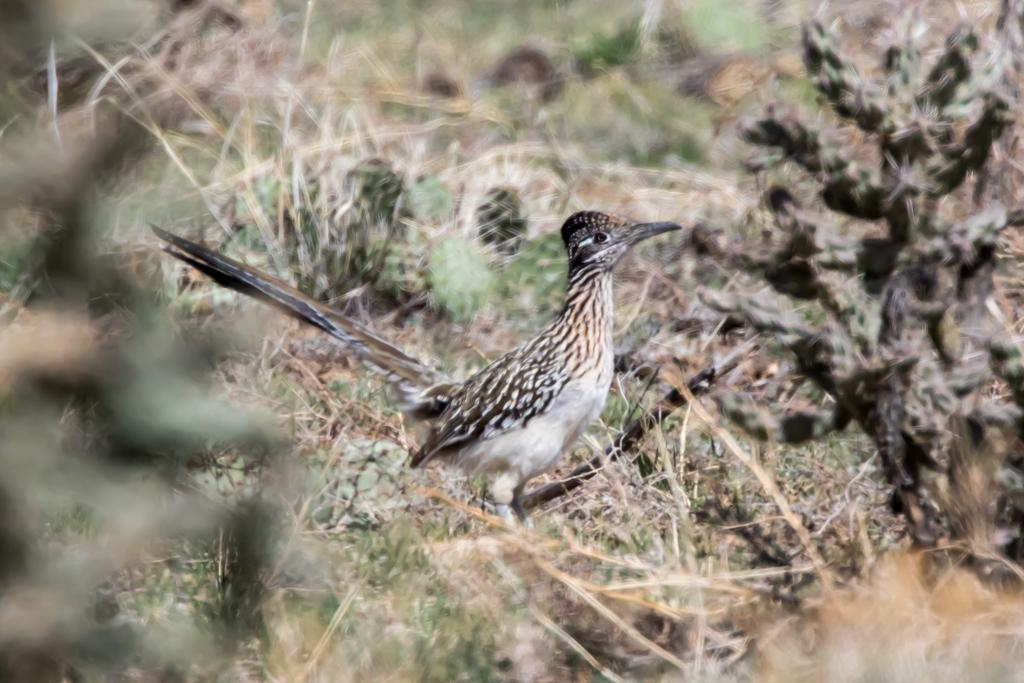What type of vegetation can be seen in the image? There is dry grass in the image. What type of animal is present in the image? There is a bird in the image. How many toes does the bird have in the image? The image does not show the bird's toes, so it cannot be determined from the image. What is the bird's position during its birth in the image? The image does not show the bird's birth, and therefore its position during birth cannot be determined. 